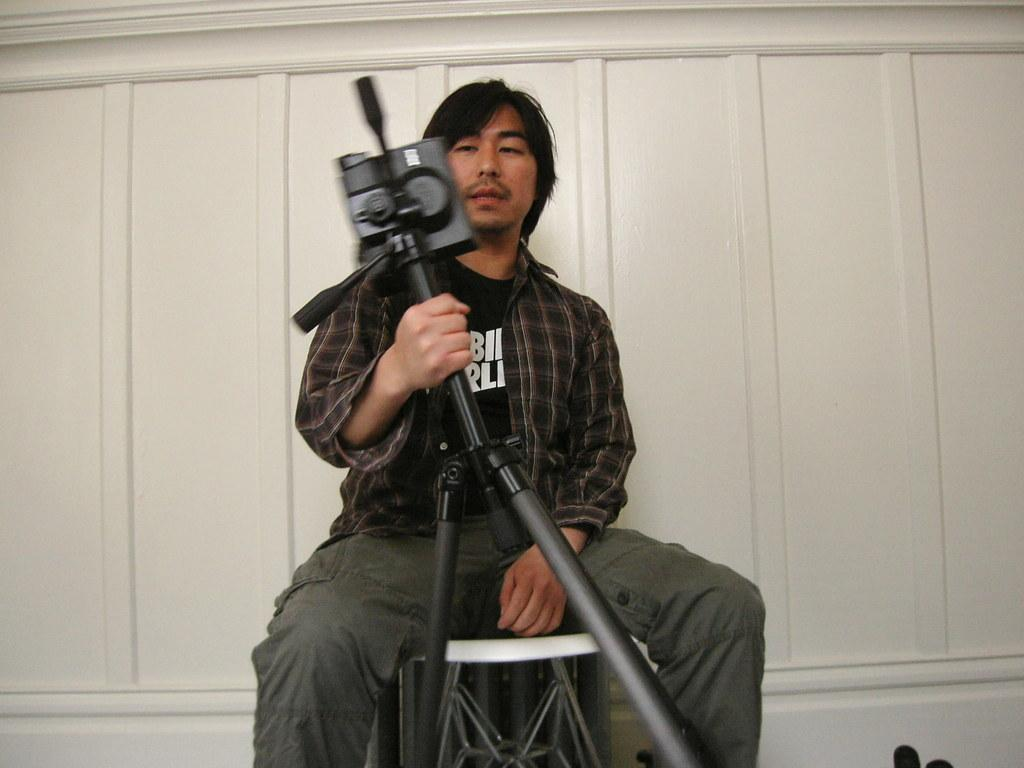Who is present in the image? There is a man in the image. What is the man doing in the image? The man is sitting on a stool. What is the man holding in the image? The man is holding a black tripod. What can be seen in the background of the image? There is a white wall in the background of the image. What type of tooth is visible in the image? There is no tooth present in the image. How much credit does the man have in the image? There is no mention of credit in the image. 